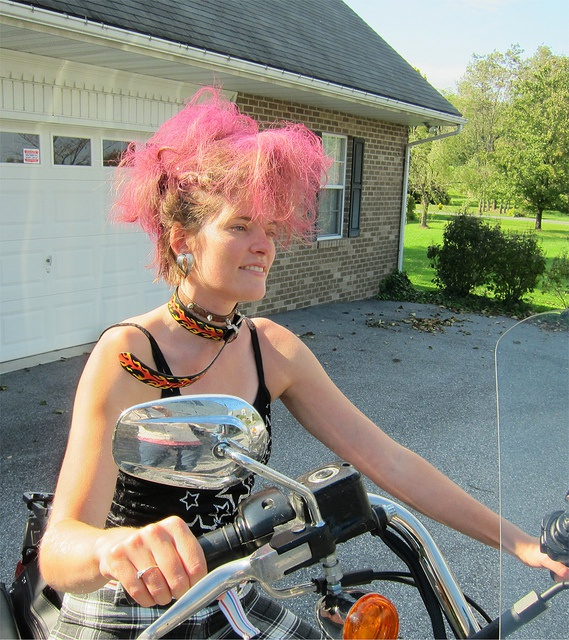Describe the objects in this image and their specific colors. I can see people in beige, salmon, and tan tones and motorcycle in beige, black, darkgray, and gray tones in this image. 